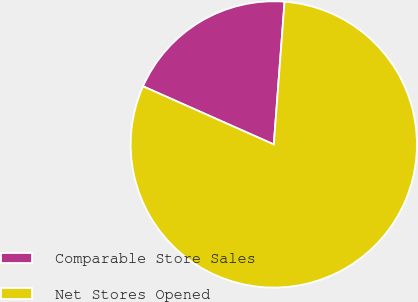<chart> <loc_0><loc_0><loc_500><loc_500><pie_chart><fcel>Comparable Store Sales<fcel>Net Stores Opened<nl><fcel>19.54%<fcel>80.46%<nl></chart> 